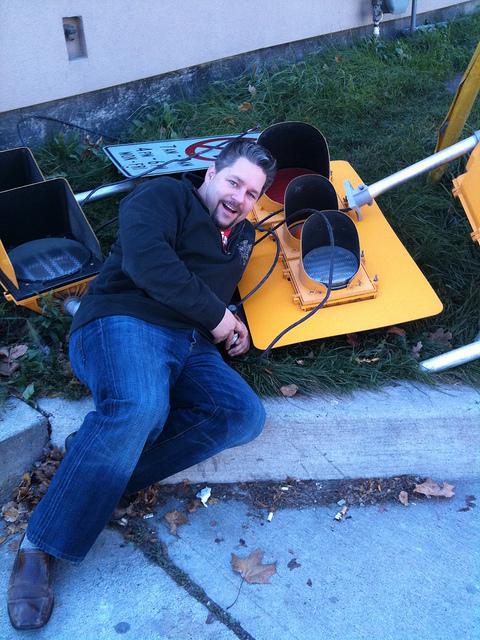Are these yellow items in the right place?
Write a very short answer. No. Is anything not on the ground?
Give a very brief answer. No. Why is the sign knocked over?
Quick response, please. Accident. 